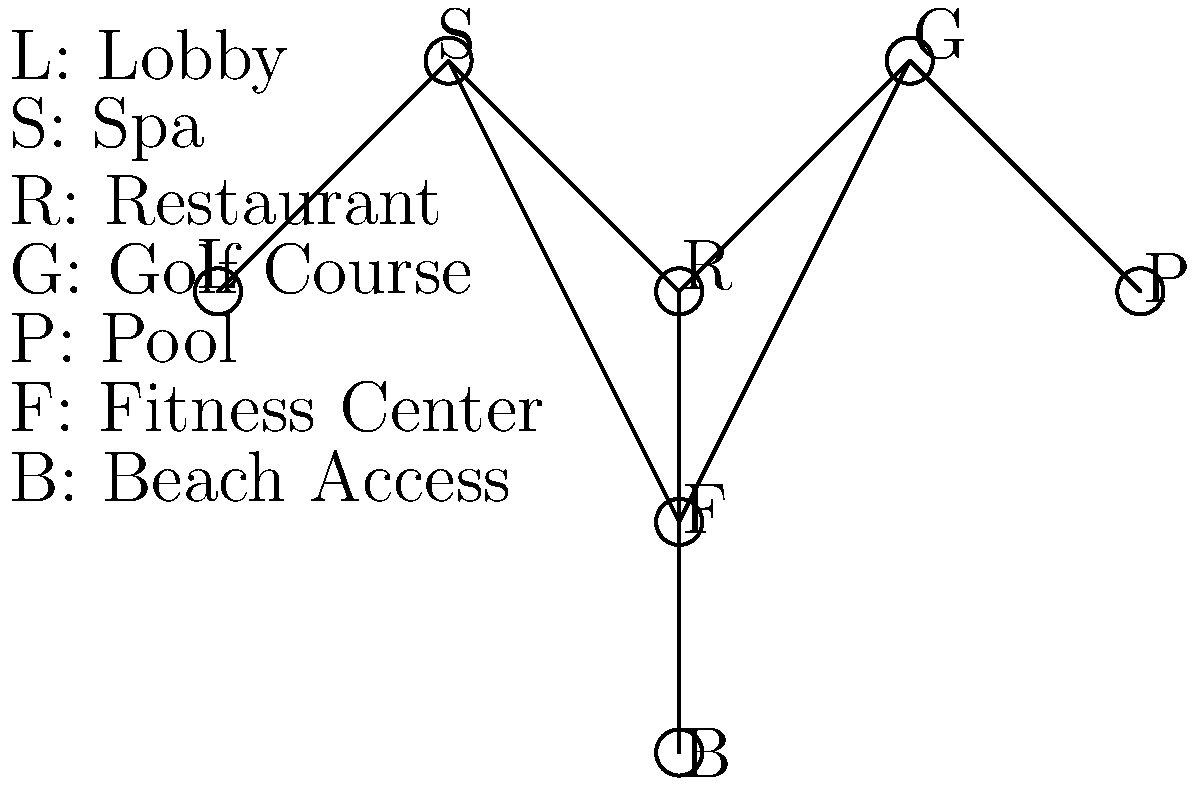As a luxury resort developer, you're tasked with optimizing the layout of amenities to minimize guest travel time. The planar graph represents the possible connections between amenities, where each node is an amenity and each edge represents a direct path. What is the minimum number of edges that need to be traversed to visit all amenities, starting and ending at the Lobby (L), while ensuring the most efficient route for guests? To find the most efficient route that visits all amenities, we need to solve the Traveling Salesman Problem (TSP) on this graph. However, since the graph is planar and has a specific structure, we can solve it by inspection:

1. Start at the Lobby (L)
2. Move to Spa (S)
3. Continue to Restaurant (R)
4. Go down to Fitness Center (F)
5. Proceed to Beach Access (B)
6. Return to Fitness Center (F)
7. Move to Restaurant (R)
8. Go to Golf Course (G)
9. Continue to Pool (P)
10. Return to Lobby (L)

This route visits all nodes (amenities) exactly once, except for R and F which are visited twice due to the graph's structure. The total number of edges traversed is 9:

$$(L-S) + (S-R) + (R-F) + (F-B) + (B-F) + (F-R) + (R-G) + (G-P) + (P-L) = 9$$

This is the minimum number of edges required to visit all amenities and return to the starting point (Lobby). Any other route would either miss some amenities or require more edge traversals.
Answer: 9 edges 